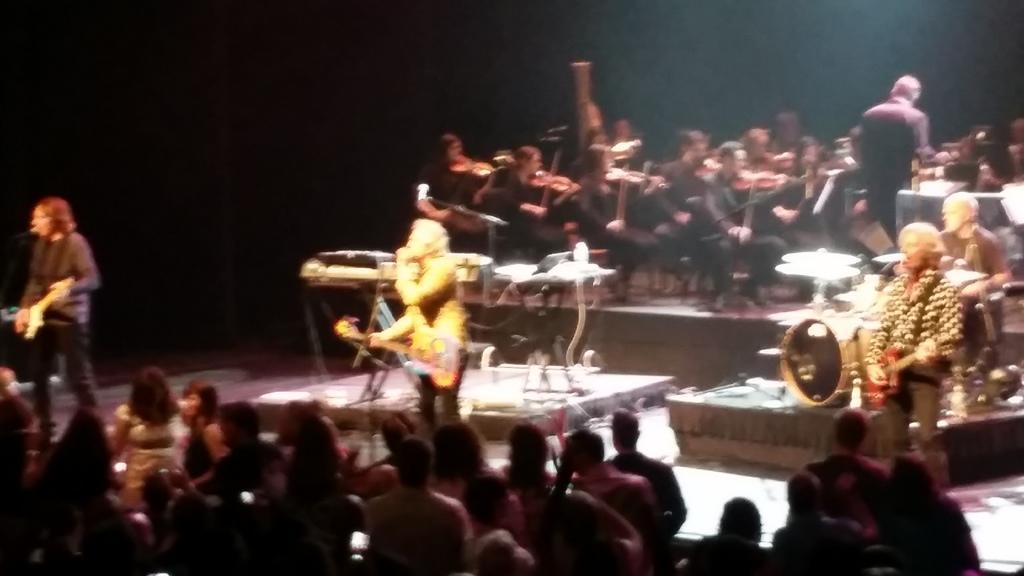Please provide a concise description of this image. In the center of the image a man is standing and holding guitar, mic. In the middle of the image we can see musical instruments. At the top of the image we can see a group of people are sitting and holding musical instrument in their hand. At the bottom of the image a group of people are there. On the left side of the image a man is standing and holding a guitar and singing and there's a mic. On the right side of the image we can see some persons and musical instruments. 